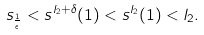Convert formula to latex. <formula><loc_0><loc_0><loc_500><loc_500>s _ { \frac { 1 } { \epsilon } } < s ^ { l _ { 2 } + \delta } ( 1 ) < s ^ { l _ { 2 } } ( 1 ) < l _ { 2 } .</formula> 